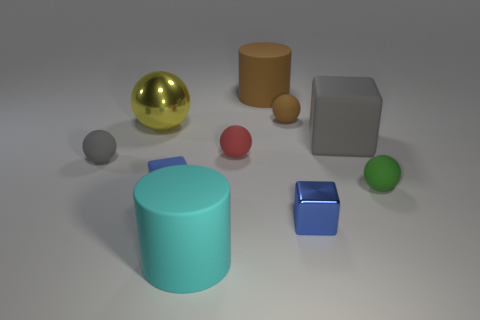Subtract all big matte blocks. How many blocks are left? 2 Subtract all blocks. How many objects are left? 7 Subtract 2 cubes. How many cubes are left? 1 Subtract all red balls. How many balls are left? 4 Subtract all gray cylinders. How many brown balls are left? 1 Subtract all small brown things. Subtract all blue blocks. How many objects are left? 7 Add 8 gray cubes. How many gray cubes are left? 9 Add 4 tiny blue shiny things. How many tiny blue shiny things exist? 5 Subtract 0 cyan blocks. How many objects are left? 10 Subtract all red blocks. Subtract all purple balls. How many blocks are left? 3 